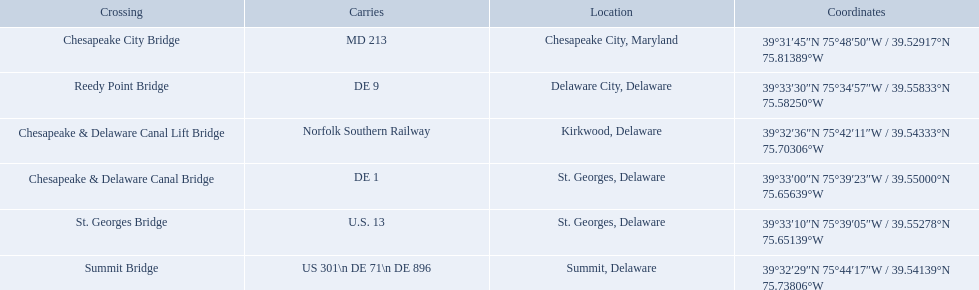What gets carried within the canal? MD 213, US 301\n DE 71\n DE 896, Norfolk Southern Railway, DE 1, U.S. 13, DE 9. Could you parse the entire table? {'header': ['Crossing', 'Carries', 'Location', 'Coordinates'], 'rows': [['Chesapeake City Bridge', 'MD 213', 'Chesapeake City, Maryland', '39°31′45″N 75°48′50″W\ufeff / \ufeff39.52917°N 75.81389°W'], ['Reedy Point Bridge', 'DE\xa09', 'Delaware City, Delaware', '39°33′30″N 75°34′57″W\ufeff / \ufeff39.55833°N 75.58250°W'], ['Chesapeake & Delaware Canal Lift Bridge', 'Norfolk Southern Railway', 'Kirkwood, Delaware', '39°32′36″N 75°42′11″W\ufeff / \ufeff39.54333°N 75.70306°W'], ['Chesapeake & Delaware Canal Bridge', 'DE 1', 'St.\xa0Georges, Delaware', '39°33′00″N 75°39′23″W\ufeff / \ufeff39.55000°N 75.65639°W'], ['St.\xa0Georges Bridge', 'U.S.\xa013', 'St.\xa0Georges, Delaware', '39°33′10″N 75°39′05″W\ufeff / \ufeff39.55278°N 75.65139°W'], ['Summit Bridge', 'US 301\\n DE 71\\n DE 896', 'Summit, Delaware', '39°32′29″N 75°44′17″W\ufeff / \ufeff39.54139°N 75.73806°W']]} Which of those carries de 9? DE 9. To what crossing does that entry correspond? Reedy Point Bridge. Which bridges are in delaware? Summit Bridge, Chesapeake & Delaware Canal Lift Bridge, Chesapeake & Delaware Canal Bridge, St. Georges Bridge, Reedy Point Bridge. Which delaware bridge carries de 9? Reedy Point Bridge. 